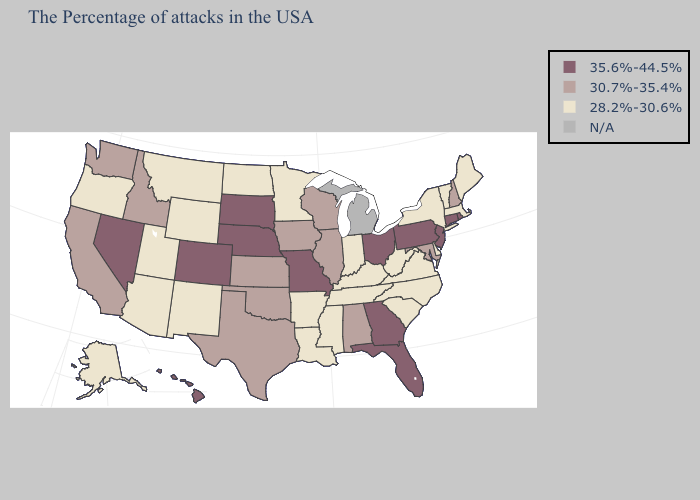What is the highest value in the Northeast ?
Short answer required. 35.6%-44.5%. Does the map have missing data?
Short answer required. Yes. Name the states that have a value in the range 30.7%-35.4%?
Keep it brief. New Hampshire, Maryland, Alabama, Wisconsin, Illinois, Iowa, Kansas, Oklahoma, Texas, Idaho, California, Washington. What is the highest value in the USA?
Quick response, please. 35.6%-44.5%. Among the states that border Ohio , does Pennsylvania have the highest value?
Give a very brief answer. Yes. Is the legend a continuous bar?
Give a very brief answer. No. Which states hav the highest value in the South?
Be succinct. Florida, Georgia. Does the first symbol in the legend represent the smallest category?
Answer briefly. No. Name the states that have a value in the range N/A?
Answer briefly. Michigan. Does the map have missing data?
Quick response, please. Yes. How many symbols are there in the legend?
Give a very brief answer. 4. What is the value of Virginia?
Concise answer only. 28.2%-30.6%. Does Maine have the lowest value in the Northeast?
Short answer required. Yes. 